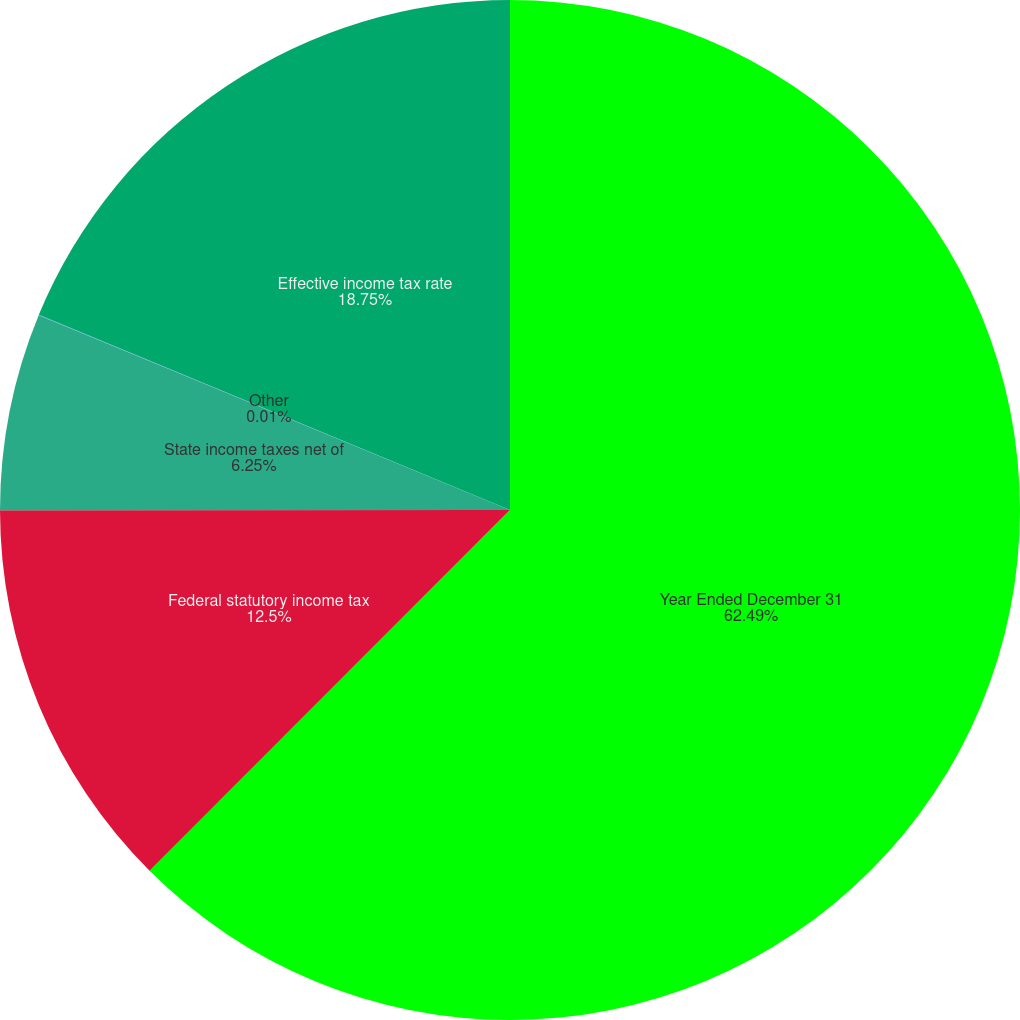Convert chart to OTSL. <chart><loc_0><loc_0><loc_500><loc_500><pie_chart><fcel>Year Ended December 31<fcel>Federal statutory income tax<fcel>State income taxes net of<fcel>Other<fcel>Effective income tax rate<nl><fcel>62.49%<fcel>12.5%<fcel>6.25%<fcel>0.01%<fcel>18.75%<nl></chart> 